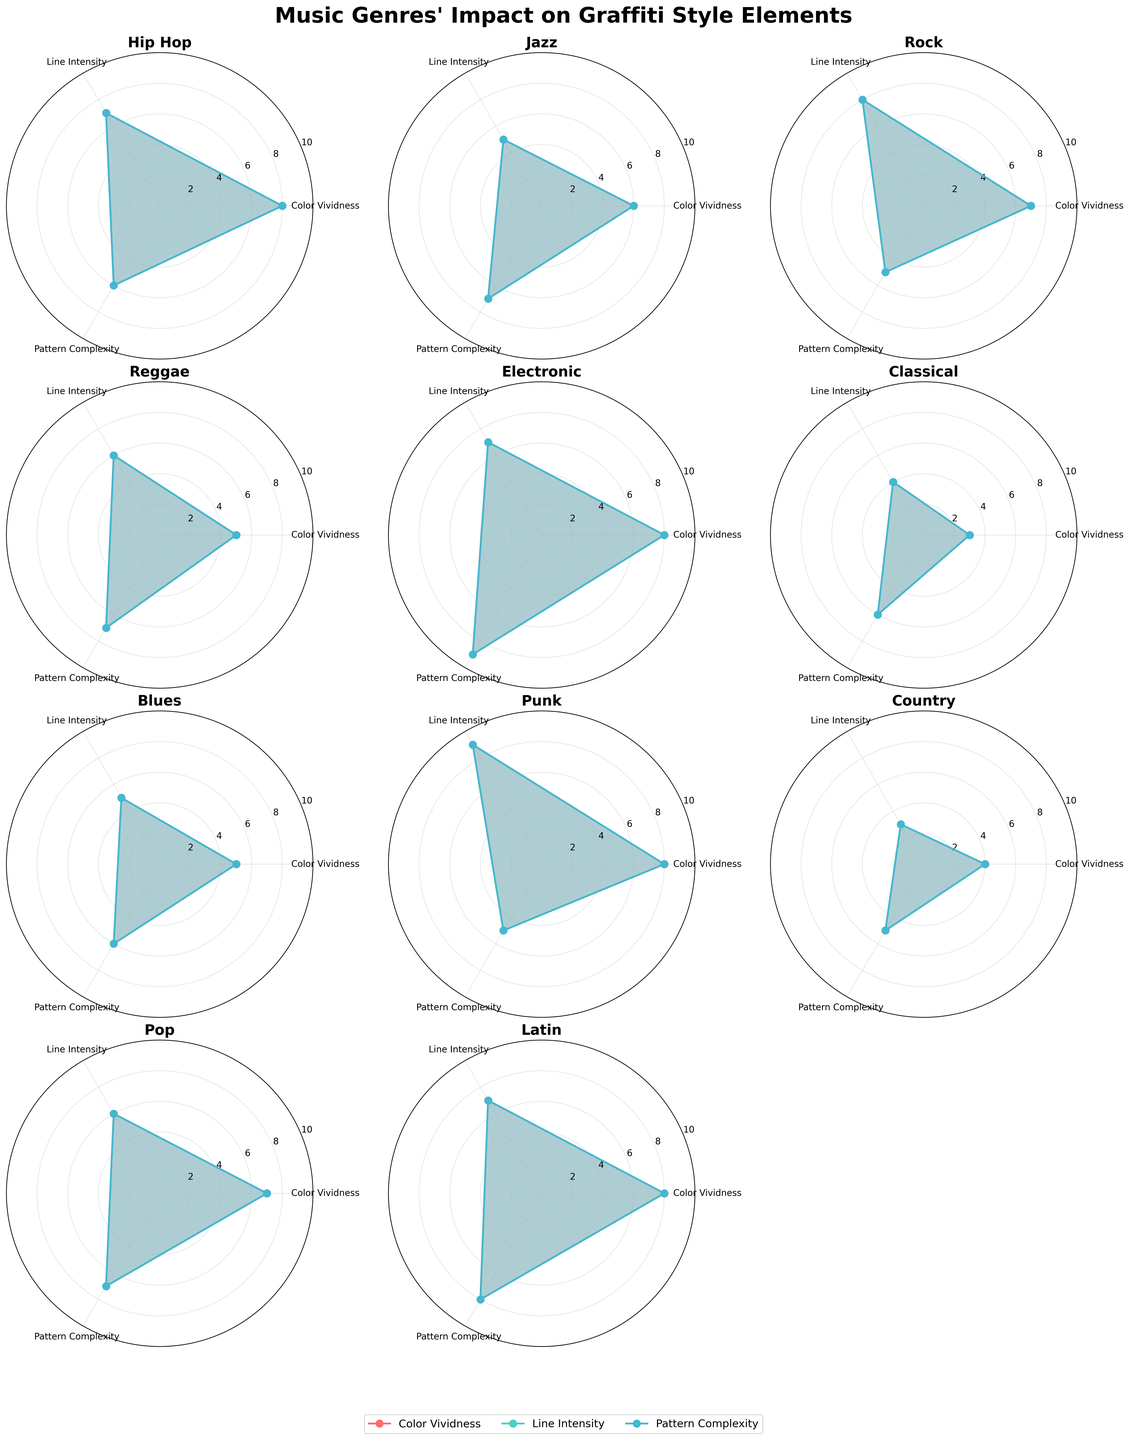Which genre has the highest color vividness? We look at the values for "Color Vividness" across all genres. Hip Hop, Electronic, Punk, and Latin each have a color vividness of 8, which is the highest.
Answer: Hip Hop, Electronic, Punk, Latin What is the average line intensity for Jazz and Classical genres? Jazz has a line intensity of 5, and Classical has a line intensity of 4. Adding these together gives 9; dividing by 2 for the average gives 4.5.
Answer: 4.5 Which genre has the lowest pattern complexity? By comparing the values of "Pattern Complexity" for all genres, we see that Rock, Punk, and Country all have the lowest value of 5.
Answer: Rock, Punk, Country How does the complexity of patterns in Pop compare to that in Electronic music? Pop has a pattern complexity of 7, while Electronic has a pattern complexity of 9. 9 is greater than 7.
Answer: Electronic has more complex patterns than Pop Among all genres, which one exhibits the highest line intensity? We compare the values for "Line Intensity" and find that Punk has the highest intensity with a value of 9.
Answer: Punk Do Rock and Hip Hop have similar color vividness levels? Both Rock and Hip Hop have a color vividness value of 8, indicating they have similar levels.
Answer: Yes Is there a genre that scores consistently low across all style elements? By reviewing the values for each attribute, we notice that Classical has relatively low scores: 3 for color vividness, 4 for line intensity, and 6 for pattern complexity.
Answer: Classical Compare the pattern complexity between Latin and Blues music. Latin has a pattern complexity of 8, while Blues has a pattern complexity of 6. 8 is greater than 6.
Answer: Latin has higher pattern complexity than Blues Which genre has the closest score for all three style elements? Hip Hop has the scores 8, 7, and 6 for color vividness, line intensity, and pattern complexity, respectively, which are quite close to each other.
Answer: Hip Hop What’s the overall trend in line intensity for Electronic, Hip Hop, and Punk genres? Electronic and Hip Hop both have a line intensity of 7, while Punk has a slightly higher intensity of 9. These observations suggest that these genres generally trend towards high line intensities.
Answer: High line intensity for all 